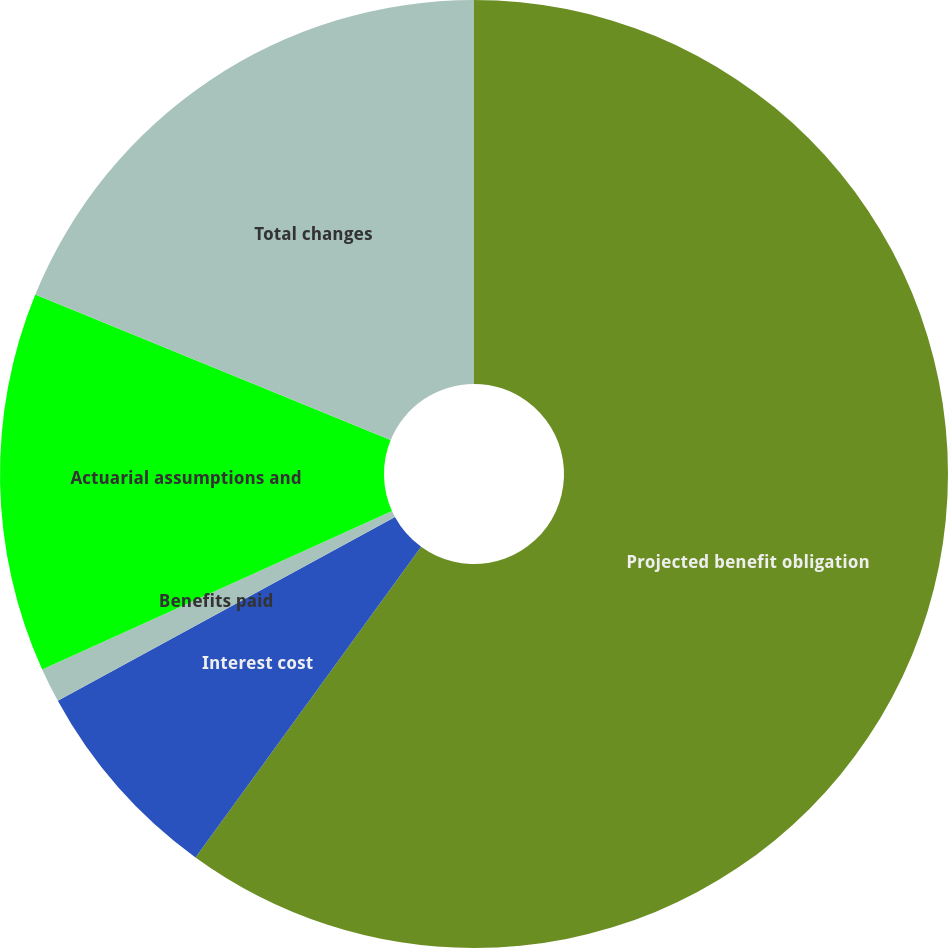Convert chart to OTSL. <chart><loc_0><loc_0><loc_500><loc_500><pie_chart><fcel>Projected benefit obligation<fcel>Interest cost<fcel>Benefits paid<fcel>Actuarial assumptions and<fcel>Total changes<nl><fcel>59.99%<fcel>7.06%<fcel>1.18%<fcel>12.94%<fcel>18.82%<nl></chart> 